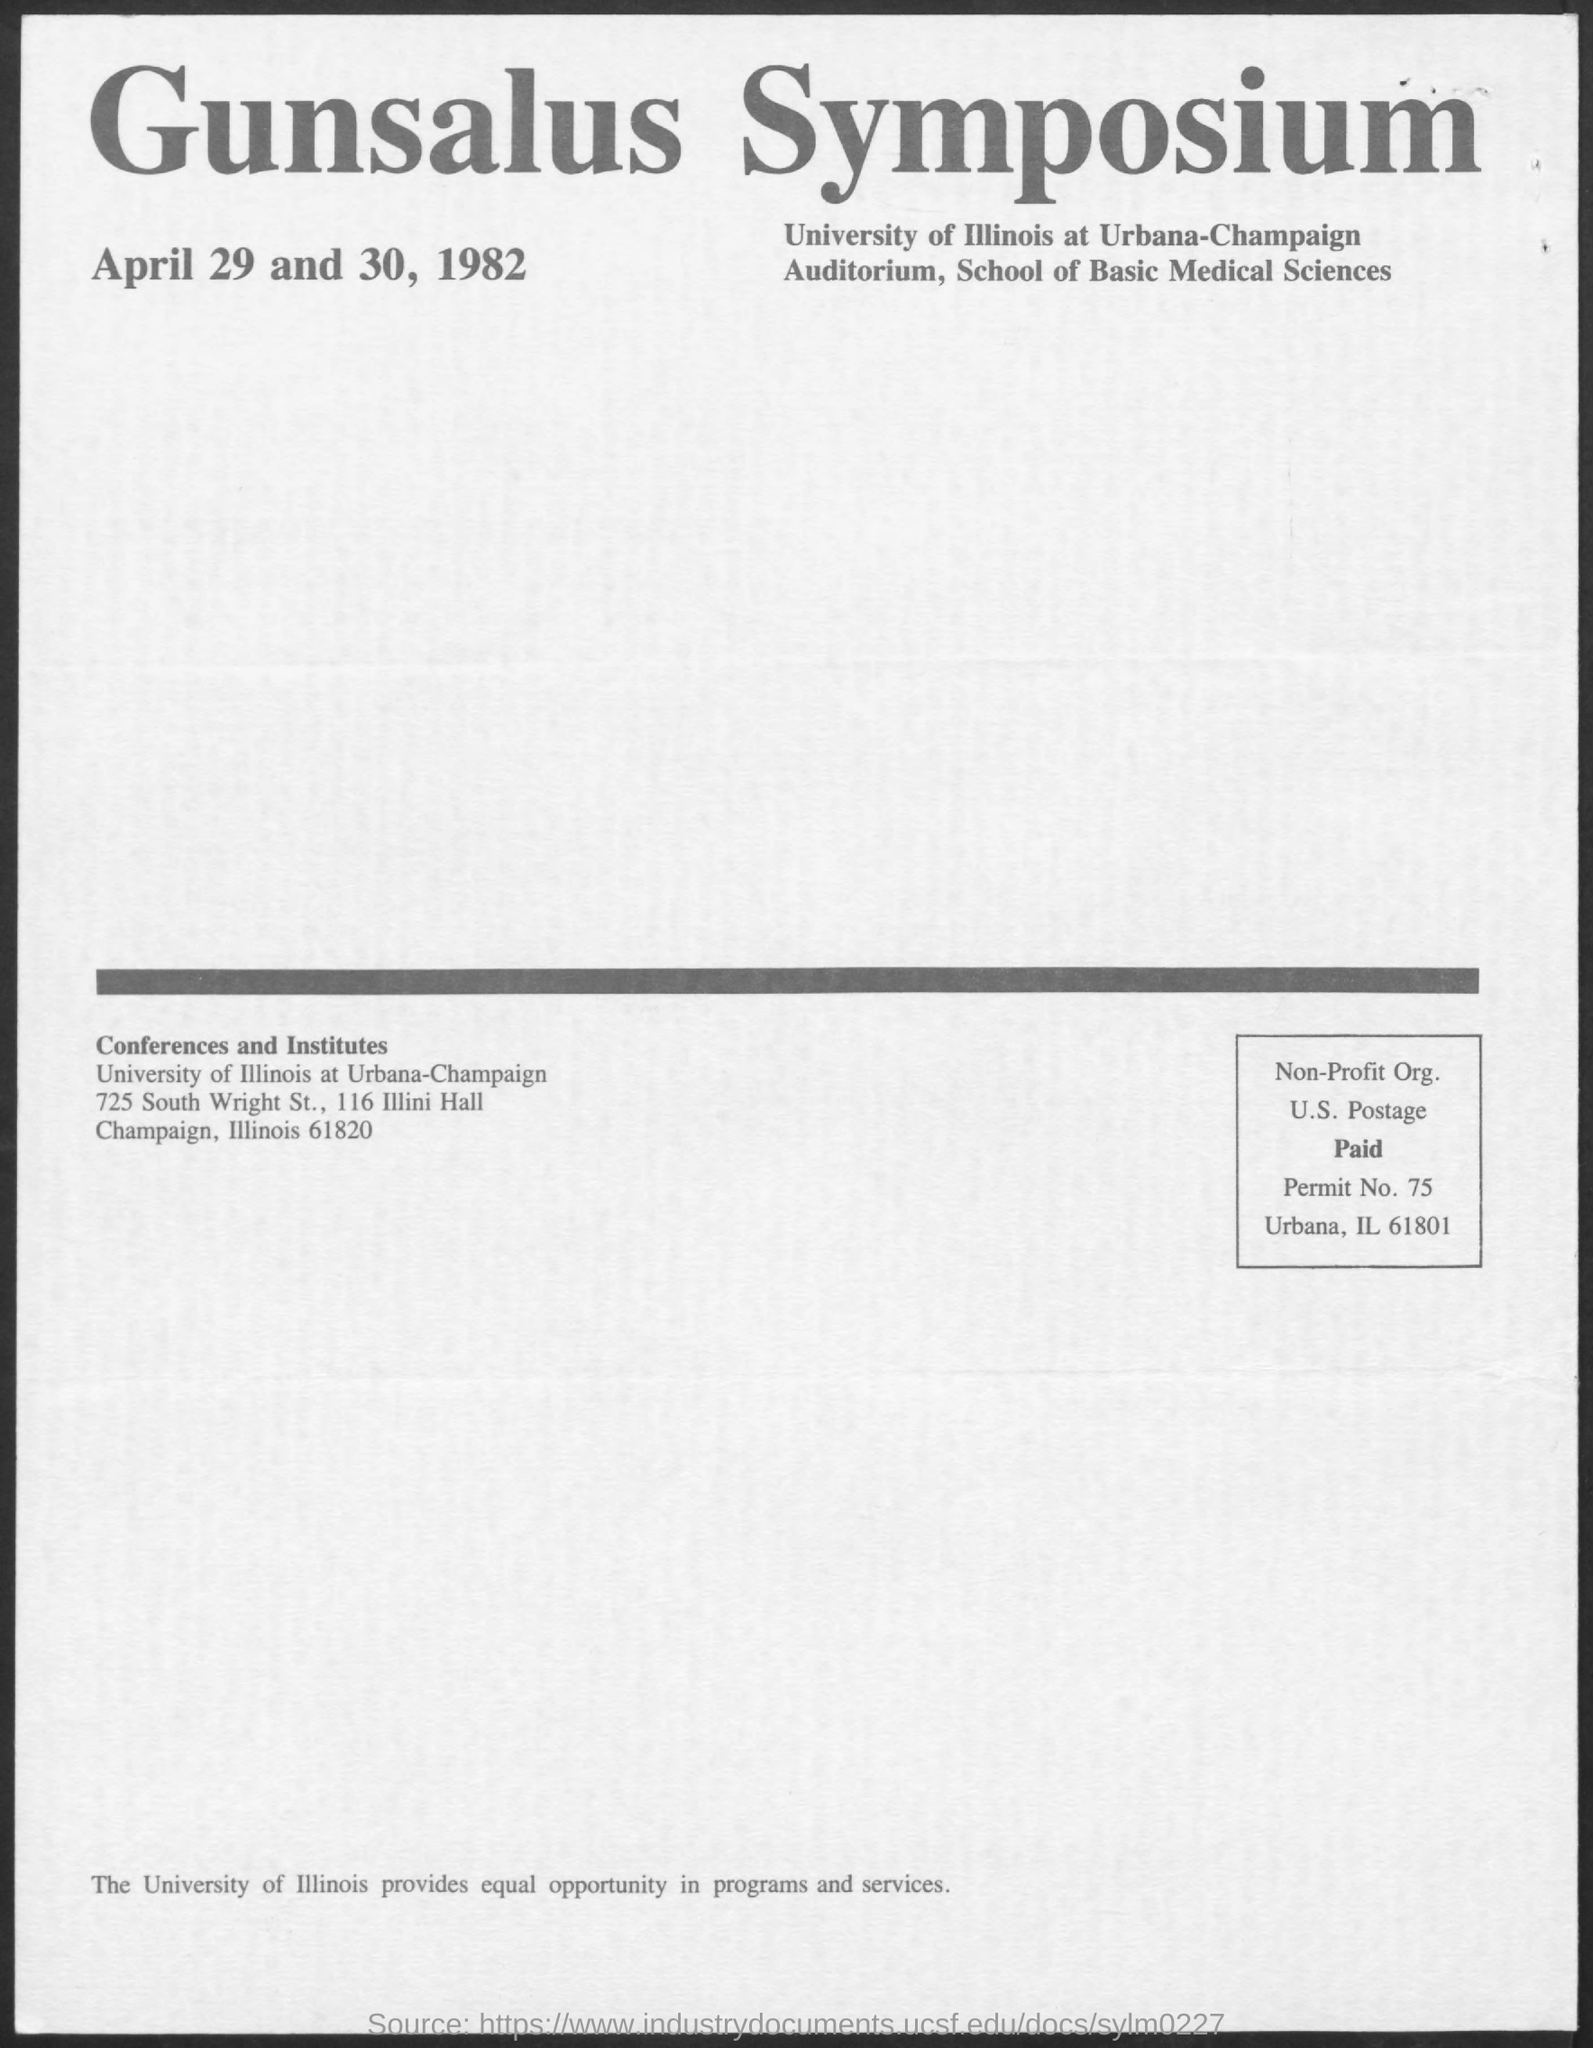Point out several critical features in this image. The permit number mentioned in this document is 75.. 